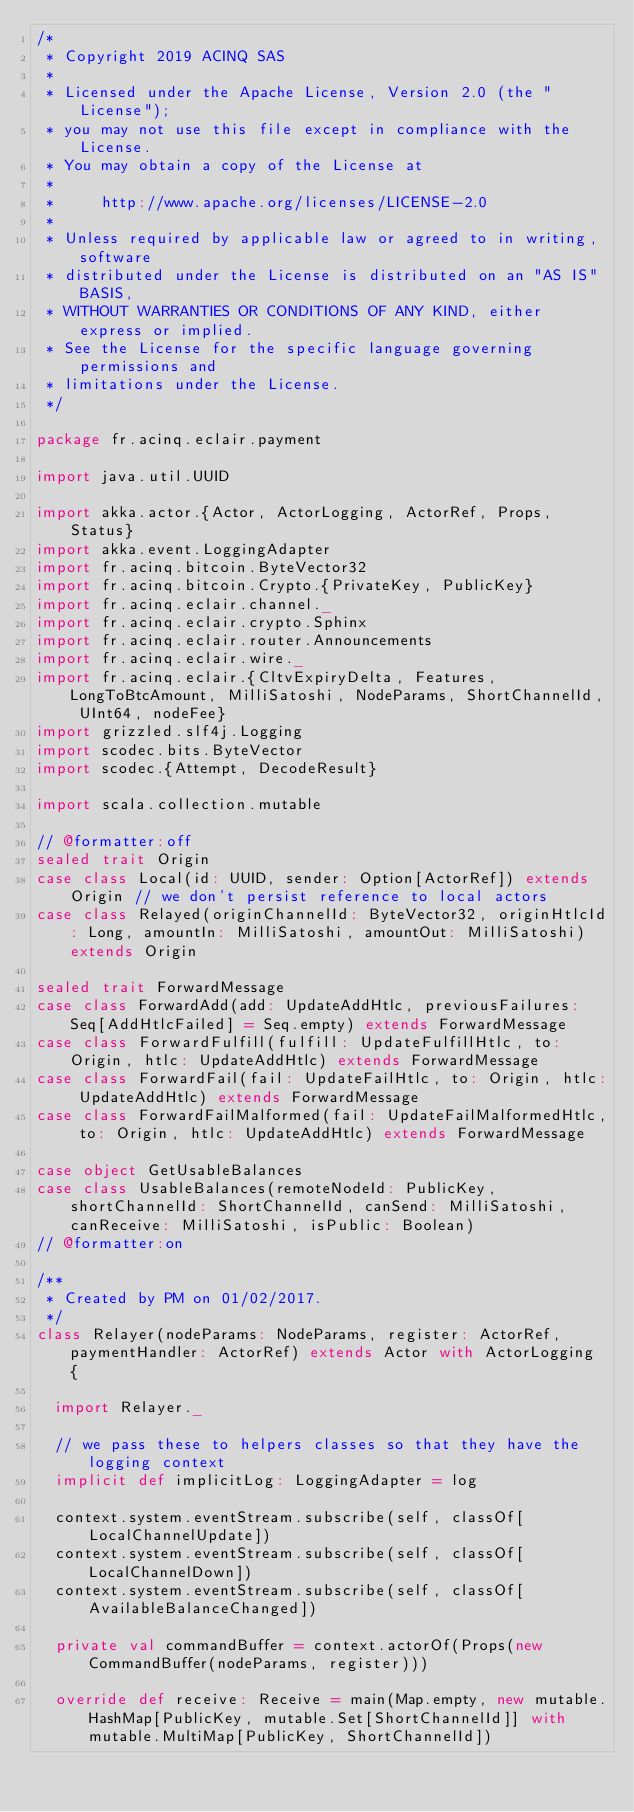Convert code to text. <code><loc_0><loc_0><loc_500><loc_500><_Scala_>/*
 * Copyright 2019 ACINQ SAS
 *
 * Licensed under the Apache License, Version 2.0 (the "License");
 * you may not use this file except in compliance with the License.
 * You may obtain a copy of the License at
 *
 *     http://www.apache.org/licenses/LICENSE-2.0
 *
 * Unless required by applicable law or agreed to in writing, software
 * distributed under the License is distributed on an "AS IS" BASIS,
 * WITHOUT WARRANTIES OR CONDITIONS OF ANY KIND, either express or implied.
 * See the License for the specific language governing permissions and
 * limitations under the License.
 */

package fr.acinq.eclair.payment

import java.util.UUID

import akka.actor.{Actor, ActorLogging, ActorRef, Props, Status}
import akka.event.LoggingAdapter
import fr.acinq.bitcoin.ByteVector32
import fr.acinq.bitcoin.Crypto.{PrivateKey, PublicKey}
import fr.acinq.eclair.channel._
import fr.acinq.eclair.crypto.Sphinx
import fr.acinq.eclair.router.Announcements
import fr.acinq.eclair.wire._
import fr.acinq.eclair.{CltvExpiryDelta, Features, LongToBtcAmount, MilliSatoshi, NodeParams, ShortChannelId, UInt64, nodeFee}
import grizzled.slf4j.Logging
import scodec.bits.ByteVector
import scodec.{Attempt, DecodeResult}

import scala.collection.mutable

// @formatter:off
sealed trait Origin
case class Local(id: UUID, sender: Option[ActorRef]) extends Origin // we don't persist reference to local actors
case class Relayed(originChannelId: ByteVector32, originHtlcId: Long, amountIn: MilliSatoshi, amountOut: MilliSatoshi) extends Origin

sealed trait ForwardMessage
case class ForwardAdd(add: UpdateAddHtlc, previousFailures: Seq[AddHtlcFailed] = Seq.empty) extends ForwardMessage
case class ForwardFulfill(fulfill: UpdateFulfillHtlc, to: Origin, htlc: UpdateAddHtlc) extends ForwardMessage
case class ForwardFail(fail: UpdateFailHtlc, to: Origin, htlc: UpdateAddHtlc) extends ForwardMessage
case class ForwardFailMalformed(fail: UpdateFailMalformedHtlc, to: Origin, htlc: UpdateAddHtlc) extends ForwardMessage

case object GetUsableBalances
case class UsableBalances(remoteNodeId: PublicKey, shortChannelId: ShortChannelId, canSend: MilliSatoshi, canReceive: MilliSatoshi, isPublic: Boolean)
// @formatter:on

/**
 * Created by PM on 01/02/2017.
 */
class Relayer(nodeParams: NodeParams, register: ActorRef, paymentHandler: ActorRef) extends Actor with ActorLogging {

  import Relayer._

  // we pass these to helpers classes so that they have the logging context
  implicit def implicitLog: LoggingAdapter = log

  context.system.eventStream.subscribe(self, classOf[LocalChannelUpdate])
  context.system.eventStream.subscribe(self, classOf[LocalChannelDown])
  context.system.eventStream.subscribe(self, classOf[AvailableBalanceChanged])

  private val commandBuffer = context.actorOf(Props(new CommandBuffer(nodeParams, register)))

  override def receive: Receive = main(Map.empty, new mutable.HashMap[PublicKey, mutable.Set[ShortChannelId]] with mutable.MultiMap[PublicKey, ShortChannelId])
</code> 